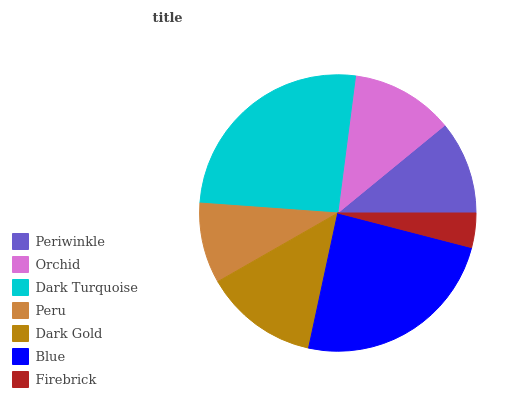Is Firebrick the minimum?
Answer yes or no. Yes. Is Dark Turquoise the maximum?
Answer yes or no. Yes. Is Orchid the minimum?
Answer yes or no. No. Is Orchid the maximum?
Answer yes or no. No. Is Orchid greater than Periwinkle?
Answer yes or no. Yes. Is Periwinkle less than Orchid?
Answer yes or no. Yes. Is Periwinkle greater than Orchid?
Answer yes or no. No. Is Orchid less than Periwinkle?
Answer yes or no. No. Is Orchid the high median?
Answer yes or no. Yes. Is Orchid the low median?
Answer yes or no. Yes. Is Blue the high median?
Answer yes or no. No. Is Periwinkle the low median?
Answer yes or no. No. 